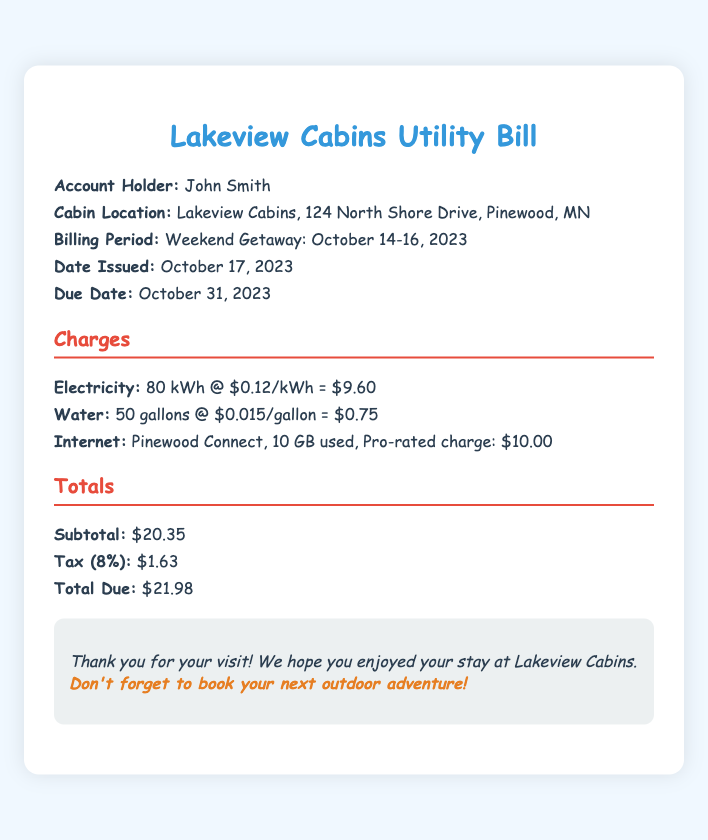What is the account holder's name? The account holder's name is listed in the header section of the document.
Answer: John Smith What is the billing period for the utility bill? The billing period is specified in the header section of the document, indicating the dates of usage.
Answer: Weekend Getaway: October 14-16, 2023 What is the subtotal of the charges? The subtotal is presented in the totals section of the document.
Answer: $20.35 How much was charged for electricity usage? The electricity charge is detailed in the charges section, specifying the usage and rate.
Answer: $9.60 What is the tax percentage applied to the total? The tax percentage is mentioned in the totals section, calculated based on the subtotal.
Answer: 8% How much was the total due? The total due amount is stated in the totals section of the document.
Answer: $21.98 How many gallons of water were used? The amount of water used is provided in the charges section of the document.
Answer: 50 gallons What is mentioned in the notes section? The notes section provides additional context and appreciation to the guest.
Answer: Thank you for your visit! We hope you enjoyed your stay at Lakeview Cabins. Don't forget to book your next outdoor adventure! What internet service was used? The internet service provider is specified in the charges section, along with the usage details.
Answer: Pinewood Connect 